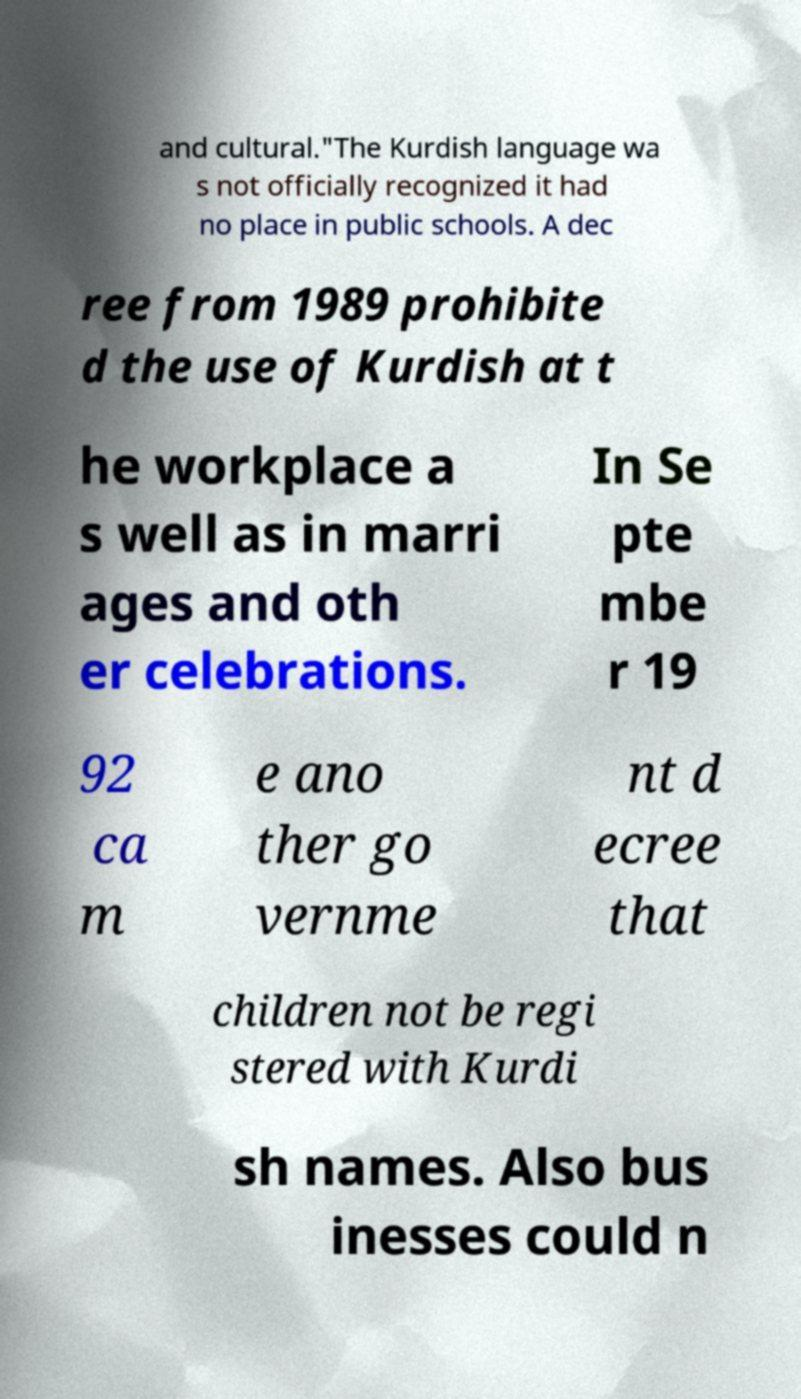For documentation purposes, I need the text within this image transcribed. Could you provide that? and cultural."The Kurdish language wa s not officially recognized it had no place in public schools. A dec ree from 1989 prohibite d the use of Kurdish at t he workplace a s well as in marri ages and oth er celebrations. In Se pte mbe r 19 92 ca m e ano ther go vernme nt d ecree that children not be regi stered with Kurdi sh names. Also bus inesses could n 